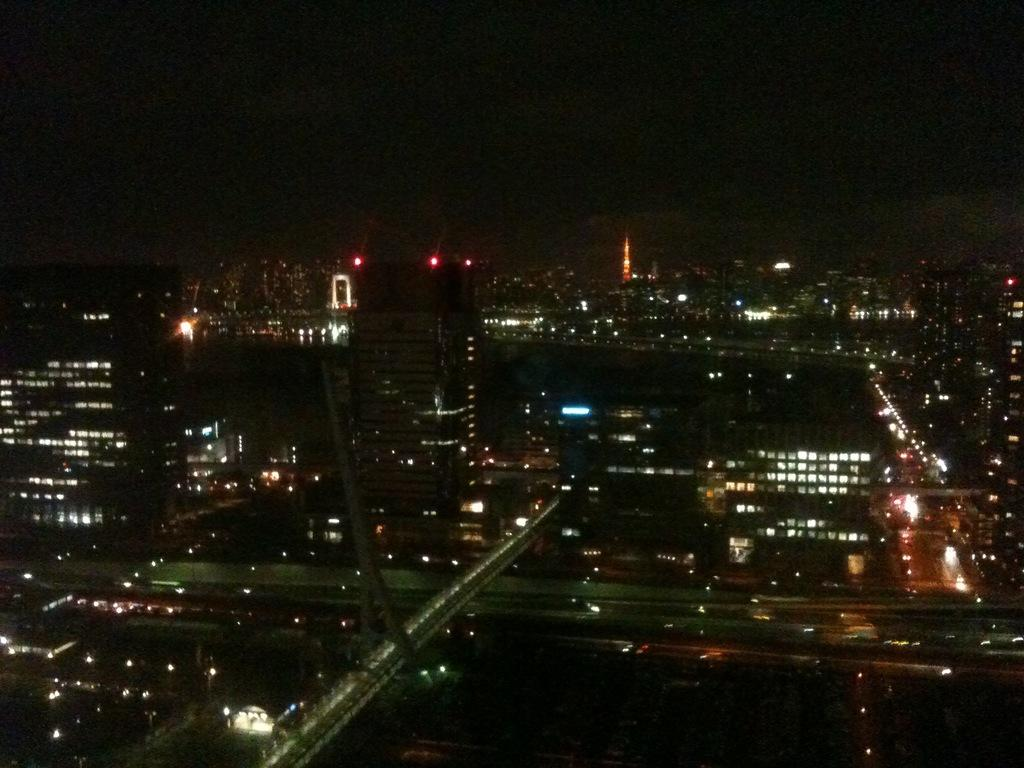What is the main subject of the image? The main subject of the image is an overview of a city. What is the lighting condition in the image? The city is in the dark in the image. What type of structures can be seen in the image? There are buildings visible in the image. What type of infrastructure is present in the image? There is a bridge in the image. What is the source of illumination in the image? Lights are present all over the image. What type of pin can be seen holding up the downtown area in the image? There is no pin present in the image, and the downtown area is not mentioned. 